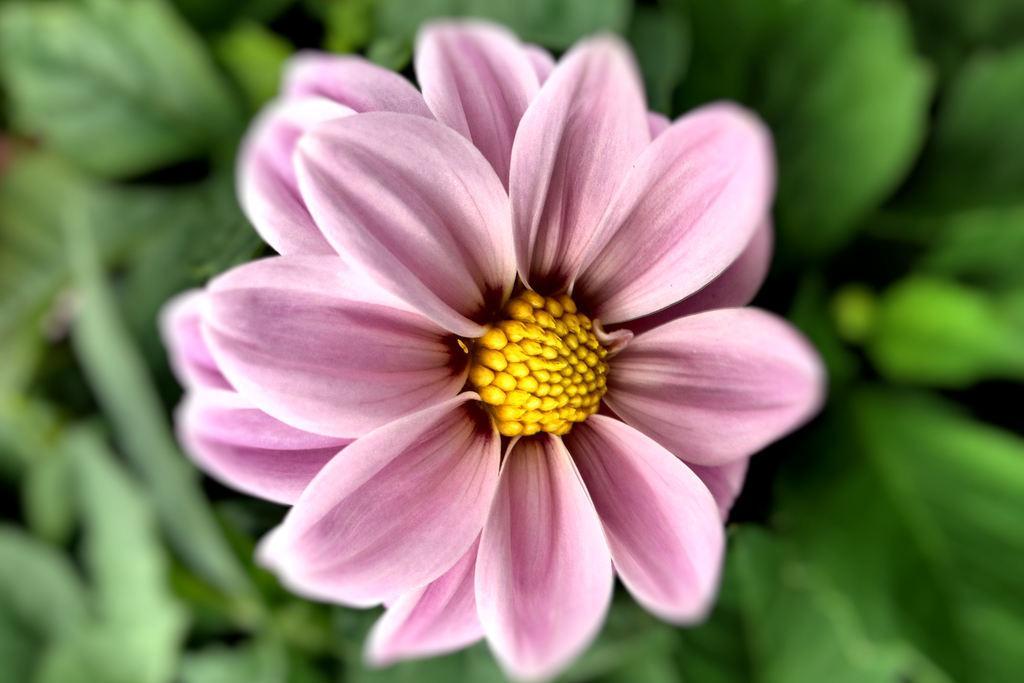How would you summarize this image in a sentence or two? In the center of the image we can see planets and one flower, which is in pink and yellow color. 